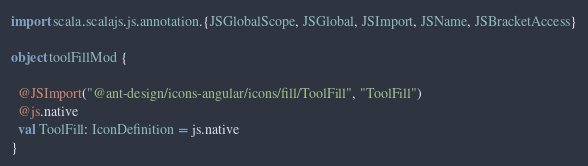Convert code to text. <code><loc_0><loc_0><loc_500><loc_500><_Scala_>import scala.scalajs.js.annotation.{JSGlobalScope, JSGlobal, JSImport, JSName, JSBracketAccess}

object toolFillMod {
  
  @JSImport("@ant-design/icons-angular/icons/fill/ToolFill", "ToolFill")
  @js.native
  val ToolFill: IconDefinition = js.native
}
</code> 